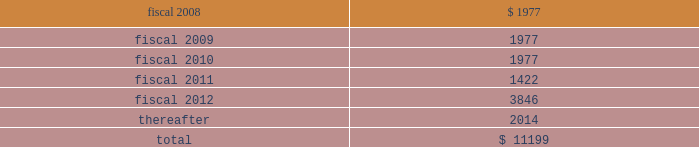Hologic , inc .
Notes to consolidated financial statements ( continued ) ( in thousands , except per share data ) future debt principal payments under these debt arrangements are approximately as follows: .
Derivative financial instruments and hedging agreements interest rate swaps in connection with the debt assumed from the aeg acquisition ( see notes 3 and 5 ) , the company acquired interest rate swap contracts used to convert the floating interest-rate component of certain debt obligations to fixed rates .
These agreements did not qualify for hedge accounting under statements of financial accounting standards no .
133 , accounting for derivative instruments and hedging activities ( 201csfas 133 201d ) and thus were marked to market each reporting period with the change in fair value recorded to other income ( expense ) , net in the accompanying consolidated statements of income .
The company terminated all outstanding interest rate swaps in the fourth quarter of fiscal 2007 which resulted in a gain of $ 75 recorded in consolidated statement of income .
Forward contracts also in connection with the aeg acquisition , the company assumed certain foreign currency forward contracts to hedge , on a net basis , the foreign currency fluctuations associated with a portion of the aeg 2019s assets and liabilities that were denominated in the us dollar , including inter-company accounts .
Increases or decreases in the company 2019s foreign currency exposures are partially offset by gains and losses on the forward contracts , so as to mitigate foreign currency transaction gains and losses .
The terms of these forward contracts are of a short- term nature ( 6 to 12 months ) .
The company does not use forward contracts for trading or speculative purposes .
The forward contracts are not designated as cash flow or fair value hedges under sfas no .
133 and do not represent effective hedges .
All outstanding forward contracts are marked to market at the end of the period and recorded on the balance sheet at fair value in other current assets and other current liabilities .
The changes in fair value from these contracts and from the underlying hedged exposures are generally offsetting were recorded in other income , net in the accompanying consolidated statements of income and these amounts were not material .
As of september 29 , 2007 , all of the forward exchange contracts assumed in the aeg acquisition had matured and the company had no forward exchange contracts outstanding .
Pension and other employee benefits in conjunction with the may 2 , 2006 acquisition of aeg , the company assumed certain defined benefit pension plans covering the employees of the aeg german subsidiary ( pension benefits ) .
On september 29 , 2006 , the fasb issued sfas no .
158 , employers 2019 accounting for defined benefit pension and other postretirement plans , an amendment of fasb statements no .
87 , 88 , 106 and 132 ( r ) ( sfas 158 ) .
Sfas 158 requires an entity to recognize in its statement of financial position an asset for a defined benefit postretirement .
What is the sum of future debt payments for the next three years? 
Computations: ((1977 + 1977) + 1977)
Answer: 5931.0. 